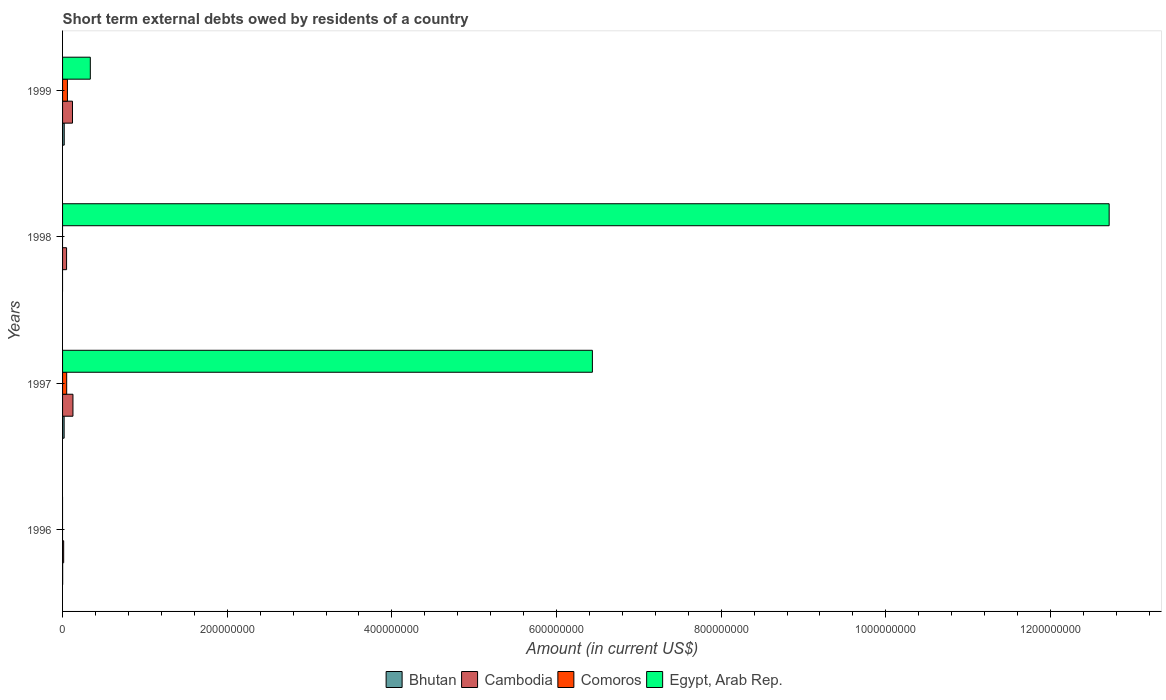What is the label of the 4th group of bars from the top?
Your answer should be compact. 1996. In how many cases, is the number of bars for a given year not equal to the number of legend labels?
Provide a short and direct response. 2. What is the amount of short-term external debts owed by residents in Egypt, Arab Rep. in 1998?
Offer a very short reply. 1.27e+09. Across all years, what is the maximum amount of short-term external debts owed by residents in Egypt, Arab Rep.?
Offer a very short reply. 1.27e+09. Across all years, what is the minimum amount of short-term external debts owed by residents in Bhutan?
Keep it short and to the point. 0. What is the total amount of short-term external debts owed by residents in Bhutan in the graph?
Your response must be concise. 4.01e+06. What is the difference between the amount of short-term external debts owed by residents in Egypt, Arab Rep. in 1997 and that in 1998?
Ensure brevity in your answer.  -6.28e+08. What is the difference between the amount of short-term external debts owed by residents in Bhutan in 1997 and the amount of short-term external debts owed by residents in Egypt, Arab Rep. in 1999?
Offer a terse response. -3.18e+07. What is the average amount of short-term external debts owed by residents in Cambodia per year?
Your response must be concise. 7.72e+06. In the year 1997, what is the difference between the amount of short-term external debts owed by residents in Cambodia and amount of short-term external debts owed by residents in Egypt, Arab Rep.?
Ensure brevity in your answer.  -6.31e+08. What is the ratio of the amount of short-term external debts owed by residents in Bhutan in 1996 to that in 1997?
Keep it short and to the point. 0.05. Is the amount of short-term external debts owed by residents in Egypt, Arab Rep. in 1997 less than that in 1999?
Keep it short and to the point. No. Is the difference between the amount of short-term external debts owed by residents in Cambodia in 1998 and 1999 greater than the difference between the amount of short-term external debts owed by residents in Egypt, Arab Rep. in 1998 and 1999?
Provide a short and direct response. No. What is the difference between the highest and the second highest amount of short-term external debts owed by residents in Egypt, Arab Rep.?
Your answer should be very brief. 6.28e+08. What is the difference between the highest and the lowest amount of short-term external debts owed by residents in Egypt, Arab Rep.?
Give a very brief answer. 1.27e+09. In how many years, is the amount of short-term external debts owed by residents in Bhutan greater than the average amount of short-term external debts owed by residents in Bhutan taken over all years?
Give a very brief answer. 2. Is the sum of the amount of short-term external debts owed by residents in Egypt, Arab Rep. in 1997 and 1999 greater than the maximum amount of short-term external debts owed by residents in Comoros across all years?
Your answer should be very brief. Yes. Is it the case that in every year, the sum of the amount of short-term external debts owed by residents in Egypt, Arab Rep. and amount of short-term external debts owed by residents in Comoros is greater than the amount of short-term external debts owed by residents in Cambodia?
Make the answer very short. No. How many bars are there?
Your answer should be compact. 12. Are all the bars in the graph horizontal?
Give a very brief answer. Yes. How many years are there in the graph?
Provide a succinct answer. 4. What is the difference between two consecutive major ticks on the X-axis?
Your answer should be compact. 2.00e+08. How many legend labels are there?
Provide a short and direct response. 4. What is the title of the graph?
Ensure brevity in your answer.  Short term external debts owed by residents of a country. What is the label or title of the X-axis?
Your answer should be very brief. Amount (in current US$). What is the Amount (in current US$) of Bhutan in 1996?
Make the answer very short. 1.04e+05. What is the Amount (in current US$) of Cambodia in 1996?
Provide a short and direct response. 1.34e+06. What is the Amount (in current US$) of Comoros in 1996?
Your answer should be compact. 0. What is the Amount (in current US$) of Bhutan in 1997?
Offer a terse response. 1.90e+06. What is the Amount (in current US$) in Cambodia in 1997?
Offer a terse response. 1.26e+07. What is the Amount (in current US$) of Comoros in 1997?
Provide a succinct answer. 5.00e+06. What is the Amount (in current US$) in Egypt, Arab Rep. in 1997?
Give a very brief answer. 6.44e+08. What is the Amount (in current US$) of Bhutan in 1998?
Your response must be concise. 0. What is the Amount (in current US$) of Cambodia in 1998?
Offer a terse response. 4.88e+06. What is the Amount (in current US$) of Egypt, Arab Rep. in 1998?
Your answer should be very brief. 1.27e+09. What is the Amount (in current US$) of Bhutan in 1999?
Your answer should be compact. 2.01e+06. What is the Amount (in current US$) of Cambodia in 1999?
Provide a succinct answer. 1.20e+07. What is the Amount (in current US$) of Comoros in 1999?
Offer a very short reply. 5.92e+06. What is the Amount (in current US$) in Egypt, Arab Rep. in 1999?
Your answer should be very brief. 3.37e+07. Across all years, what is the maximum Amount (in current US$) in Bhutan?
Offer a terse response. 2.01e+06. Across all years, what is the maximum Amount (in current US$) of Cambodia?
Provide a succinct answer. 1.26e+07. Across all years, what is the maximum Amount (in current US$) in Comoros?
Keep it short and to the point. 5.92e+06. Across all years, what is the maximum Amount (in current US$) of Egypt, Arab Rep.?
Provide a succinct answer. 1.27e+09. Across all years, what is the minimum Amount (in current US$) of Bhutan?
Ensure brevity in your answer.  0. Across all years, what is the minimum Amount (in current US$) of Cambodia?
Keep it short and to the point. 1.34e+06. What is the total Amount (in current US$) in Bhutan in the graph?
Offer a very short reply. 4.01e+06. What is the total Amount (in current US$) in Cambodia in the graph?
Provide a succinct answer. 3.09e+07. What is the total Amount (in current US$) in Comoros in the graph?
Offer a very short reply. 1.09e+07. What is the total Amount (in current US$) in Egypt, Arab Rep. in the graph?
Offer a very short reply. 1.95e+09. What is the difference between the Amount (in current US$) in Bhutan in 1996 and that in 1997?
Ensure brevity in your answer.  -1.79e+06. What is the difference between the Amount (in current US$) in Cambodia in 1996 and that in 1997?
Give a very brief answer. -1.13e+07. What is the difference between the Amount (in current US$) in Cambodia in 1996 and that in 1998?
Provide a succinct answer. -3.54e+06. What is the difference between the Amount (in current US$) in Bhutan in 1996 and that in 1999?
Offer a terse response. -1.91e+06. What is the difference between the Amount (in current US$) in Cambodia in 1996 and that in 1999?
Give a very brief answer. -1.07e+07. What is the difference between the Amount (in current US$) of Cambodia in 1997 and that in 1998?
Give a very brief answer. 7.74e+06. What is the difference between the Amount (in current US$) in Egypt, Arab Rep. in 1997 and that in 1998?
Ensure brevity in your answer.  -6.28e+08. What is the difference between the Amount (in current US$) of Bhutan in 1997 and that in 1999?
Your answer should be compact. -1.14e+05. What is the difference between the Amount (in current US$) in Cambodia in 1997 and that in 1999?
Keep it short and to the point. 5.70e+05. What is the difference between the Amount (in current US$) in Comoros in 1997 and that in 1999?
Offer a terse response. -9.20e+05. What is the difference between the Amount (in current US$) of Egypt, Arab Rep. in 1997 and that in 1999?
Ensure brevity in your answer.  6.10e+08. What is the difference between the Amount (in current US$) of Cambodia in 1998 and that in 1999?
Offer a terse response. -7.17e+06. What is the difference between the Amount (in current US$) of Egypt, Arab Rep. in 1998 and that in 1999?
Keep it short and to the point. 1.24e+09. What is the difference between the Amount (in current US$) in Bhutan in 1996 and the Amount (in current US$) in Cambodia in 1997?
Make the answer very short. -1.25e+07. What is the difference between the Amount (in current US$) of Bhutan in 1996 and the Amount (in current US$) of Comoros in 1997?
Offer a terse response. -4.90e+06. What is the difference between the Amount (in current US$) of Bhutan in 1996 and the Amount (in current US$) of Egypt, Arab Rep. in 1997?
Ensure brevity in your answer.  -6.43e+08. What is the difference between the Amount (in current US$) in Cambodia in 1996 and the Amount (in current US$) in Comoros in 1997?
Your answer should be very brief. -3.66e+06. What is the difference between the Amount (in current US$) in Cambodia in 1996 and the Amount (in current US$) in Egypt, Arab Rep. in 1997?
Ensure brevity in your answer.  -6.42e+08. What is the difference between the Amount (in current US$) of Bhutan in 1996 and the Amount (in current US$) of Cambodia in 1998?
Offer a terse response. -4.78e+06. What is the difference between the Amount (in current US$) in Bhutan in 1996 and the Amount (in current US$) in Egypt, Arab Rep. in 1998?
Give a very brief answer. -1.27e+09. What is the difference between the Amount (in current US$) of Cambodia in 1996 and the Amount (in current US$) of Egypt, Arab Rep. in 1998?
Provide a short and direct response. -1.27e+09. What is the difference between the Amount (in current US$) of Bhutan in 1996 and the Amount (in current US$) of Cambodia in 1999?
Provide a short and direct response. -1.19e+07. What is the difference between the Amount (in current US$) in Bhutan in 1996 and the Amount (in current US$) in Comoros in 1999?
Provide a succinct answer. -5.82e+06. What is the difference between the Amount (in current US$) in Bhutan in 1996 and the Amount (in current US$) in Egypt, Arab Rep. in 1999?
Give a very brief answer. -3.36e+07. What is the difference between the Amount (in current US$) of Cambodia in 1996 and the Amount (in current US$) of Comoros in 1999?
Provide a succinct answer. -4.58e+06. What is the difference between the Amount (in current US$) in Cambodia in 1996 and the Amount (in current US$) in Egypt, Arab Rep. in 1999?
Ensure brevity in your answer.  -3.24e+07. What is the difference between the Amount (in current US$) of Bhutan in 1997 and the Amount (in current US$) of Cambodia in 1998?
Keep it short and to the point. -2.98e+06. What is the difference between the Amount (in current US$) in Bhutan in 1997 and the Amount (in current US$) in Egypt, Arab Rep. in 1998?
Make the answer very short. -1.27e+09. What is the difference between the Amount (in current US$) in Cambodia in 1997 and the Amount (in current US$) in Egypt, Arab Rep. in 1998?
Make the answer very short. -1.26e+09. What is the difference between the Amount (in current US$) of Comoros in 1997 and the Amount (in current US$) of Egypt, Arab Rep. in 1998?
Ensure brevity in your answer.  -1.27e+09. What is the difference between the Amount (in current US$) of Bhutan in 1997 and the Amount (in current US$) of Cambodia in 1999?
Your answer should be very brief. -1.02e+07. What is the difference between the Amount (in current US$) in Bhutan in 1997 and the Amount (in current US$) in Comoros in 1999?
Your answer should be very brief. -4.02e+06. What is the difference between the Amount (in current US$) of Bhutan in 1997 and the Amount (in current US$) of Egypt, Arab Rep. in 1999?
Keep it short and to the point. -3.18e+07. What is the difference between the Amount (in current US$) in Cambodia in 1997 and the Amount (in current US$) in Comoros in 1999?
Keep it short and to the point. 6.70e+06. What is the difference between the Amount (in current US$) in Cambodia in 1997 and the Amount (in current US$) in Egypt, Arab Rep. in 1999?
Your answer should be compact. -2.11e+07. What is the difference between the Amount (in current US$) in Comoros in 1997 and the Amount (in current US$) in Egypt, Arab Rep. in 1999?
Your answer should be very brief. -2.87e+07. What is the difference between the Amount (in current US$) of Cambodia in 1998 and the Amount (in current US$) of Comoros in 1999?
Offer a very short reply. -1.04e+06. What is the difference between the Amount (in current US$) of Cambodia in 1998 and the Amount (in current US$) of Egypt, Arab Rep. in 1999?
Offer a very short reply. -2.88e+07. What is the average Amount (in current US$) in Bhutan per year?
Offer a very short reply. 1.00e+06. What is the average Amount (in current US$) in Cambodia per year?
Provide a succinct answer. 7.72e+06. What is the average Amount (in current US$) of Comoros per year?
Ensure brevity in your answer.  2.73e+06. What is the average Amount (in current US$) of Egypt, Arab Rep. per year?
Provide a short and direct response. 4.87e+08. In the year 1996, what is the difference between the Amount (in current US$) in Bhutan and Amount (in current US$) in Cambodia?
Your response must be concise. -1.24e+06. In the year 1997, what is the difference between the Amount (in current US$) of Bhutan and Amount (in current US$) of Cambodia?
Provide a succinct answer. -1.07e+07. In the year 1997, what is the difference between the Amount (in current US$) of Bhutan and Amount (in current US$) of Comoros?
Your answer should be compact. -3.10e+06. In the year 1997, what is the difference between the Amount (in current US$) of Bhutan and Amount (in current US$) of Egypt, Arab Rep.?
Offer a terse response. -6.42e+08. In the year 1997, what is the difference between the Amount (in current US$) in Cambodia and Amount (in current US$) in Comoros?
Offer a very short reply. 7.62e+06. In the year 1997, what is the difference between the Amount (in current US$) of Cambodia and Amount (in current US$) of Egypt, Arab Rep.?
Keep it short and to the point. -6.31e+08. In the year 1997, what is the difference between the Amount (in current US$) in Comoros and Amount (in current US$) in Egypt, Arab Rep.?
Give a very brief answer. -6.39e+08. In the year 1998, what is the difference between the Amount (in current US$) in Cambodia and Amount (in current US$) in Egypt, Arab Rep.?
Keep it short and to the point. -1.27e+09. In the year 1999, what is the difference between the Amount (in current US$) of Bhutan and Amount (in current US$) of Cambodia?
Offer a terse response. -1.00e+07. In the year 1999, what is the difference between the Amount (in current US$) in Bhutan and Amount (in current US$) in Comoros?
Make the answer very short. -3.91e+06. In the year 1999, what is the difference between the Amount (in current US$) in Bhutan and Amount (in current US$) in Egypt, Arab Rep.?
Your response must be concise. -3.17e+07. In the year 1999, what is the difference between the Amount (in current US$) in Cambodia and Amount (in current US$) in Comoros?
Your response must be concise. 6.13e+06. In the year 1999, what is the difference between the Amount (in current US$) of Cambodia and Amount (in current US$) of Egypt, Arab Rep.?
Your response must be concise. -2.16e+07. In the year 1999, what is the difference between the Amount (in current US$) in Comoros and Amount (in current US$) in Egypt, Arab Rep.?
Keep it short and to the point. -2.78e+07. What is the ratio of the Amount (in current US$) of Bhutan in 1996 to that in 1997?
Offer a terse response. 0.05. What is the ratio of the Amount (in current US$) in Cambodia in 1996 to that in 1997?
Make the answer very short. 0.11. What is the ratio of the Amount (in current US$) in Cambodia in 1996 to that in 1998?
Give a very brief answer. 0.27. What is the ratio of the Amount (in current US$) of Bhutan in 1996 to that in 1999?
Offer a terse response. 0.05. What is the ratio of the Amount (in current US$) in Cambodia in 1996 to that in 1999?
Ensure brevity in your answer.  0.11. What is the ratio of the Amount (in current US$) in Cambodia in 1997 to that in 1998?
Offer a very short reply. 2.59. What is the ratio of the Amount (in current US$) of Egypt, Arab Rep. in 1997 to that in 1998?
Your response must be concise. 0.51. What is the ratio of the Amount (in current US$) in Bhutan in 1997 to that in 1999?
Offer a terse response. 0.94. What is the ratio of the Amount (in current US$) of Cambodia in 1997 to that in 1999?
Your answer should be compact. 1.05. What is the ratio of the Amount (in current US$) of Comoros in 1997 to that in 1999?
Give a very brief answer. 0.84. What is the ratio of the Amount (in current US$) in Egypt, Arab Rep. in 1997 to that in 1999?
Your response must be concise. 19.1. What is the ratio of the Amount (in current US$) of Cambodia in 1998 to that in 1999?
Ensure brevity in your answer.  0.41. What is the ratio of the Amount (in current US$) in Egypt, Arab Rep. in 1998 to that in 1999?
Provide a short and direct response. 37.72. What is the difference between the highest and the second highest Amount (in current US$) in Bhutan?
Provide a succinct answer. 1.14e+05. What is the difference between the highest and the second highest Amount (in current US$) in Cambodia?
Make the answer very short. 5.70e+05. What is the difference between the highest and the second highest Amount (in current US$) of Egypt, Arab Rep.?
Ensure brevity in your answer.  6.28e+08. What is the difference between the highest and the lowest Amount (in current US$) of Bhutan?
Your answer should be very brief. 2.01e+06. What is the difference between the highest and the lowest Amount (in current US$) of Cambodia?
Offer a terse response. 1.13e+07. What is the difference between the highest and the lowest Amount (in current US$) of Comoros?
Your answer should be very brief. 5.92e+06. What is the difference between the highest and the lowest Amount (in current US$) of Egypt, Arab Rep.?
Ensure brevity in your answer.  1.27e+09. 